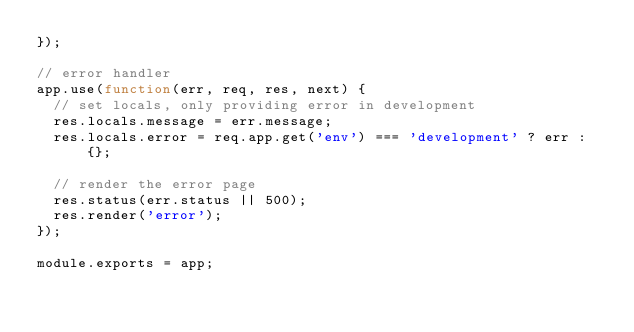Convert code to text. <code><loc_0><loc_0><loc_500><loc_500><_JavaScript_>});

// error handler
app.use(function(err, req, res, next) {
  // set locals, only providing error in development
  res.locals.message = err.message;
  res.locals.error = req.app.get('env') === 'development' ? err : {};

  // render the error page
  res.status(err.status || 500);
  res.render('error');
});

module.exports = app;
</code> 